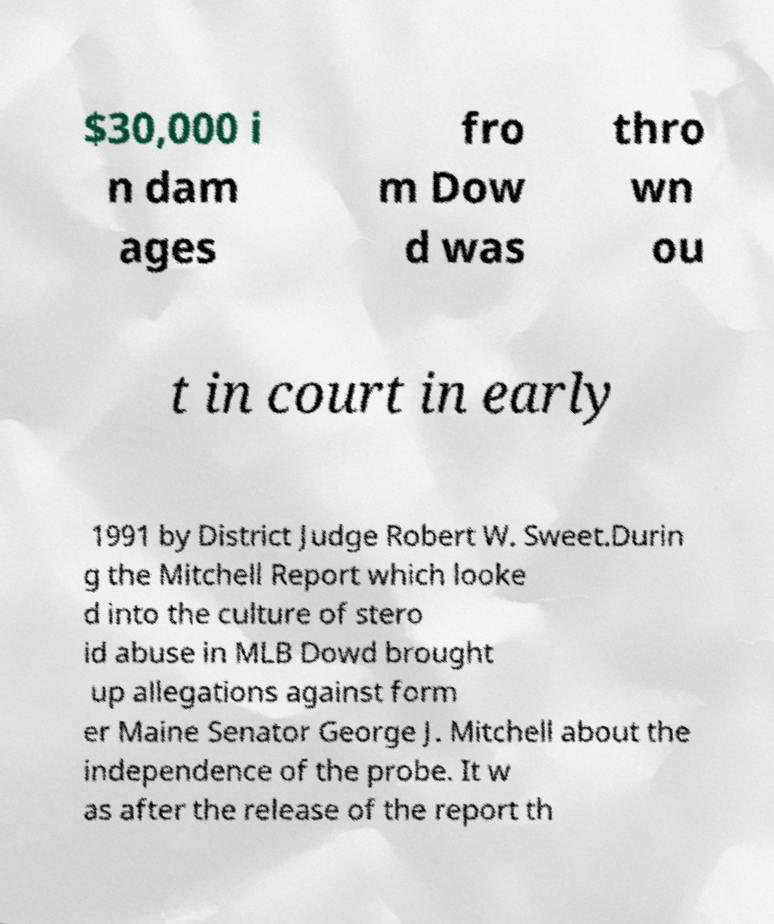Could you extract and type out the text from this image? $30,000 i n dam ages fro m Dow d was thro wn ou t in court in early 1991 by District Judge Robert W. Sweet.Durin g the Mitchell Report which looke d into the culture of stero id abuse in MLB Dowd brought up allegations against form er Maine Senator George J. Mitchell about the independence of the probe. It w as after the release of the report th 